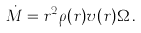<formula> <loc_0><loc_0><loc_500><loc_500>\dot { M } = r ^ { 2 } { \rho } { ( r ) } v ( r ) \Omega \, .</formula> 